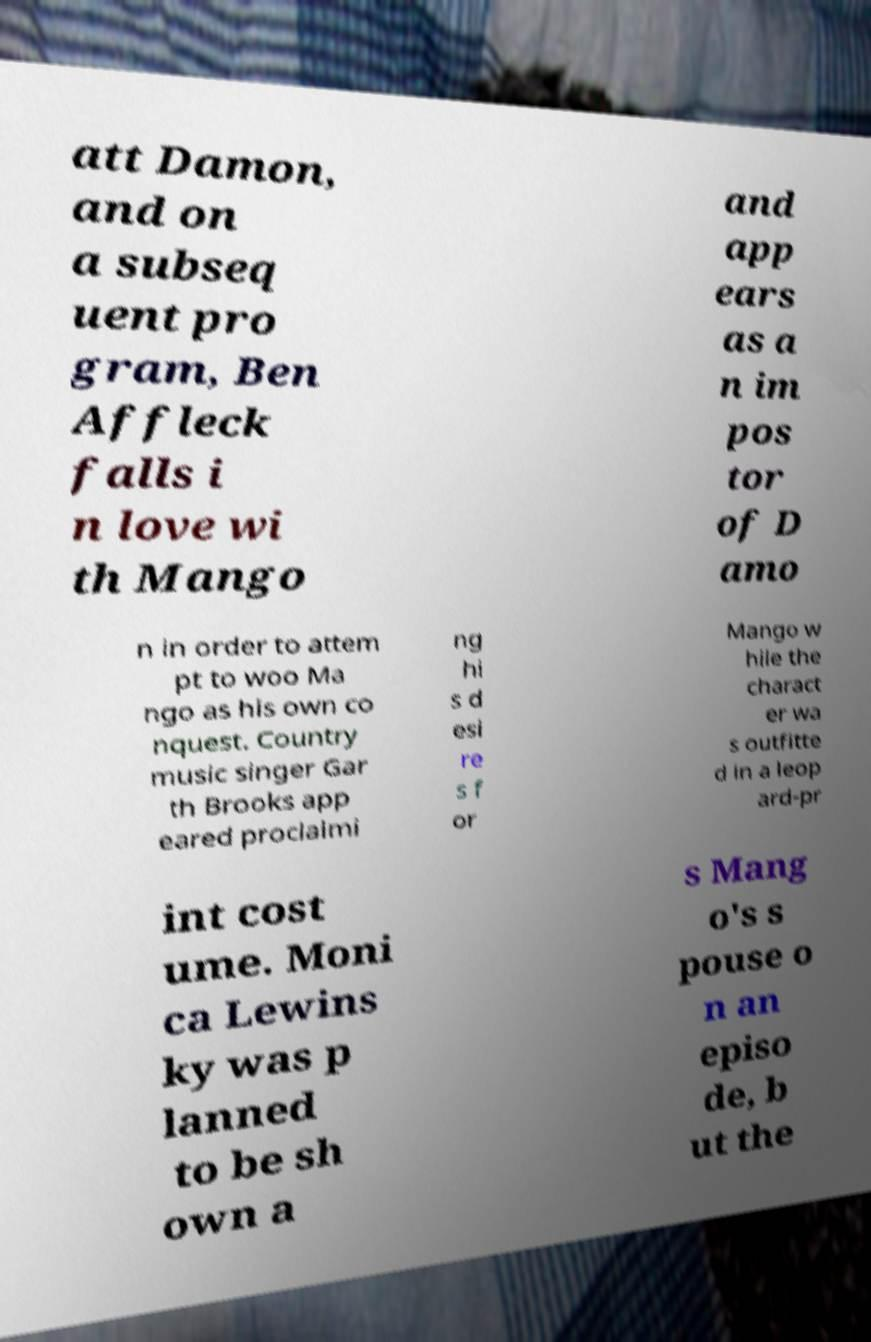I need the written content from this picture converted into text. Can you do that? att Damon, and on a subseq uent pro gram, Ben Affleck falls i n love wi th Mango and app ears as a n im pos tor of D amo n in order to attem pt to woo Ma ngo as his own co nquest. Country music singer Gar th Brooks app eared proclaimi ng hi s d esi re s f or Mango w hile the charact er wa s outfitte d in a leop ard-pr int cost ume. Moni ca Lewins ky was p lanned to be sh own a s Mang o's s pouse o n an episo de, b ut the 